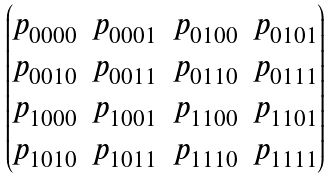Convert formula to latex. <formula><loc_0><loc_0><loc_500><loc_500>\begin{pmatrix} p _ { 0 0 0 0 } & p _ { 0 0 0 1 } & p _ { 0 1 0 0 } & p _ { 0 1 0 1 } \\ p _ { 0 0 1 0 } & p _ { 0 0 1 1 } & p _ { 0 1 1 0 } & p _ { 0 1 1 1 } \\ p _ { 1 0 0 0 } & p _ { 1 0 0 1 } & p _ { 1 1 0 0 } & p _ { 1 1 0 1 } \\ p _ { 1 0 1 0 } & p _ { 1 0 1 1 } & p _ { 1 1 1 0 } & p _ { 1 1 1 1 } \end{pmatrix}</formula> 